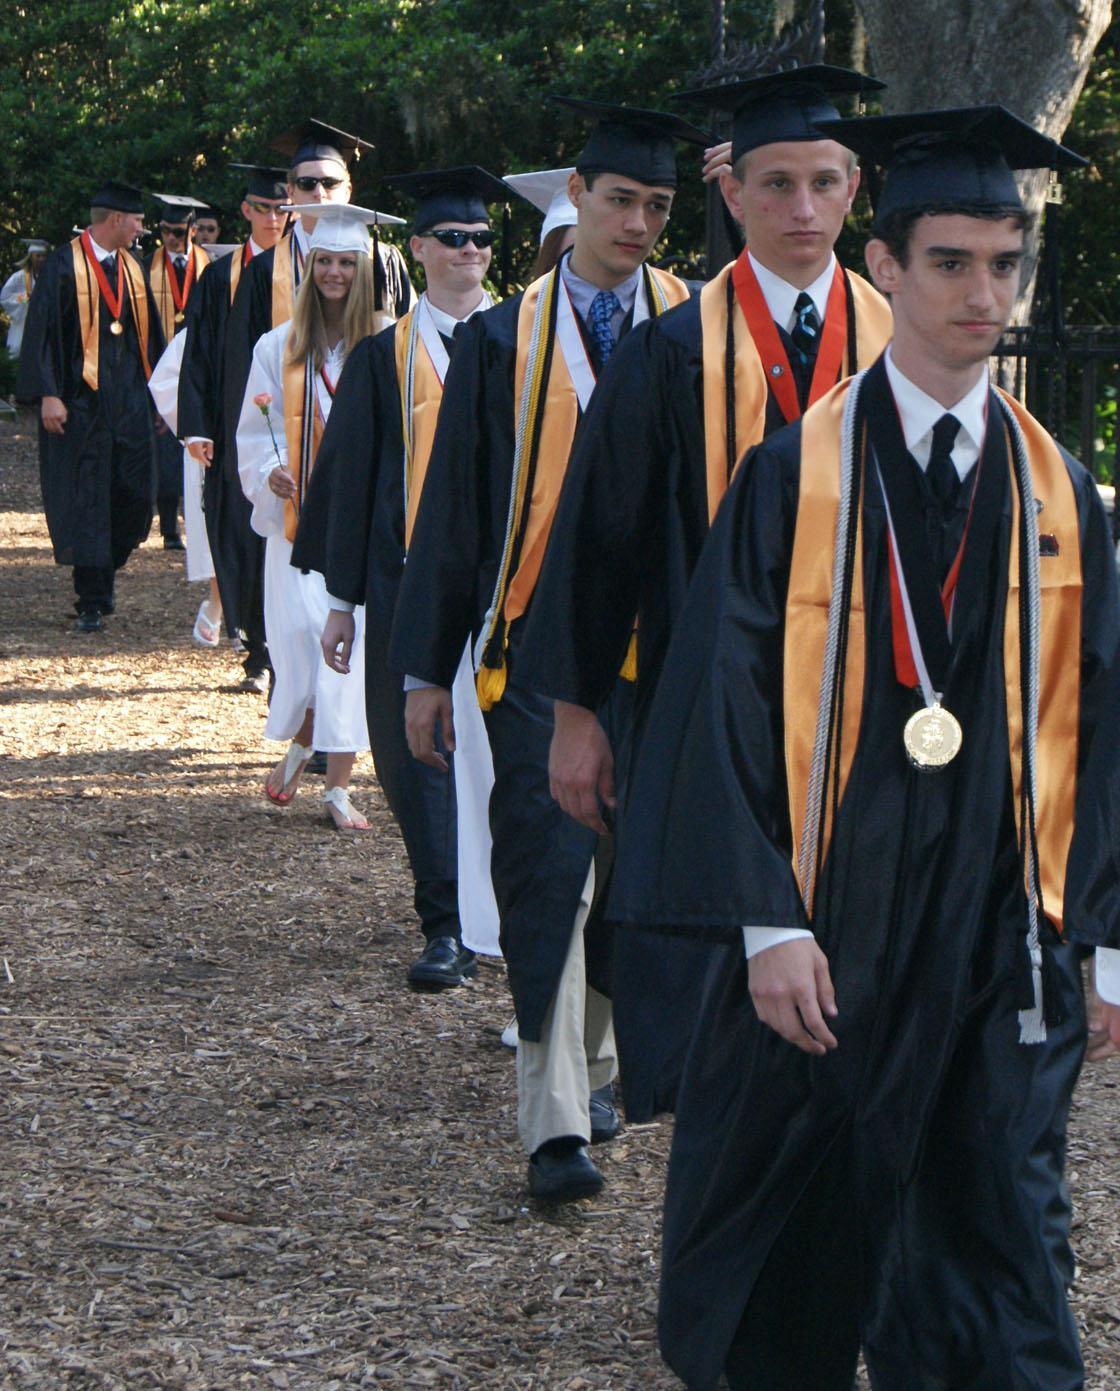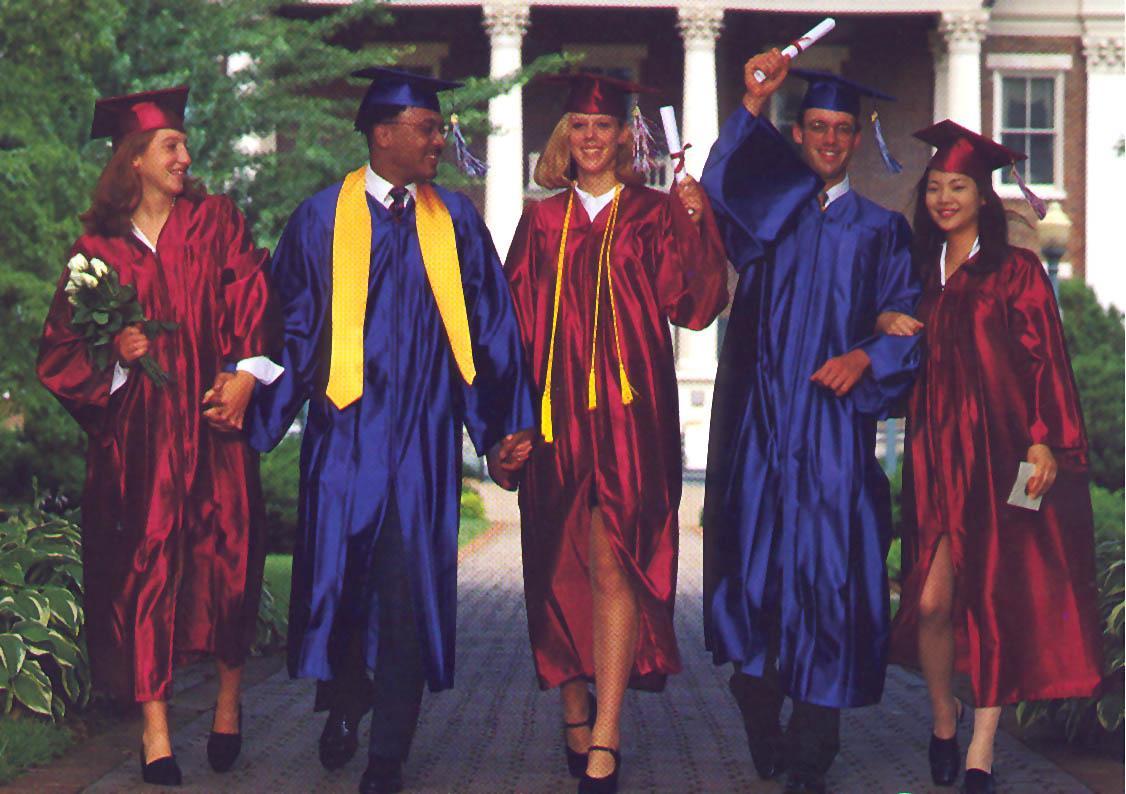The first image is the image on the left, the second image is the image on the right. Evaluate the accuracy of this statement regarding the images: "All graduates in each image are wearing identical gowns and sashes.". Is it true? Answer yes or no. No. The first image is the image on the left, the second image is the image on the right. Given the left and right images, does the statement "At least three camera-facing graduates in burgundy robes are in one image." hold true? Answer yes or no. Yes. The first image is the image on the left, the second image is the image on the right. Analyze the images presented: Is the assertion "An image includes multiple graduates in wine-colored gowns." valid? Answer yes or no. Yes. The first image is the image on the left, the second image is the image on the right. Analyze the images presented: Is the assertion "In one image, at least three graduates are wearing red gowns and caps, while a second image shows at least four graduates in black gowns with gold sashes." valid? Answer yes or no. Yes. 